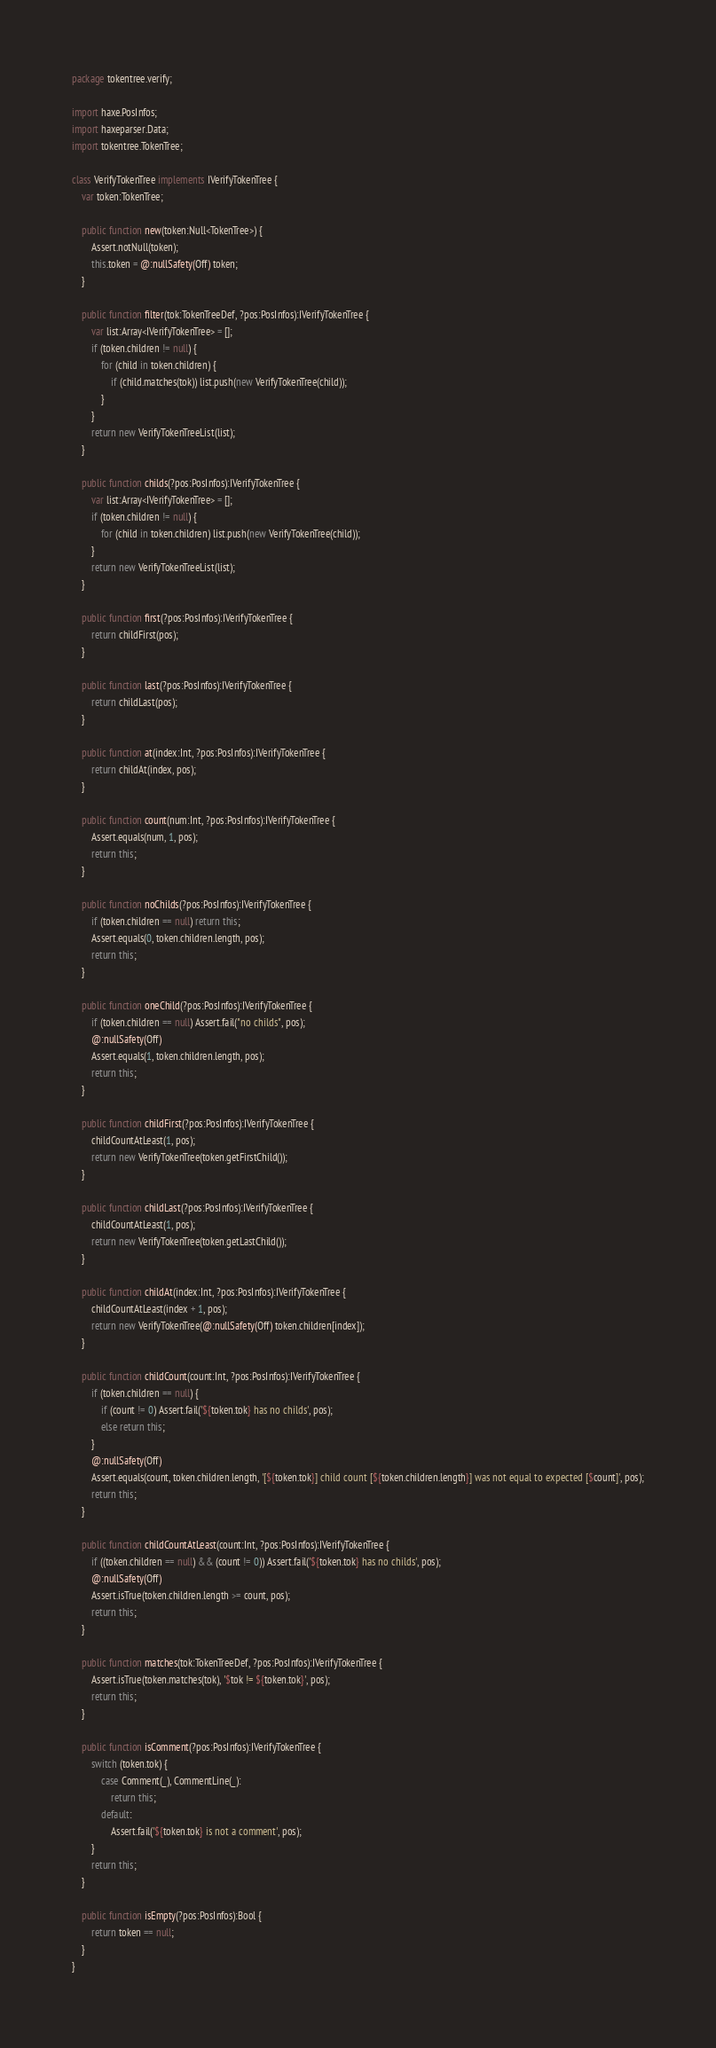<code> <loc_0><loc_0><loc_500><loc_500><_Haxe_>package tokentree.verify;

import haxe.PosInfos;
import haxeparser.Data;
import tokentree.TokenTree;

class VerifyTokenTree implements IVerifyTokenTree {
	var token:TokenTree;

	public function new(token:Null<TokenTree>) {
		Assert.notNull(token);
		this.token = @:nullSafety(Off) token;
	}

	public function filter(tok:TokenTreeDef, ?pos:PosInfos):IVerifyTokenTree {
		var list:Array<IVerifyTokenTree> = [];
		if (token.children != null) {
			for (child in token.children) {
				if (child.matches(tok)) list.push(new VerifyTokenTree(child));
			}
		}
		return new VerifyTokenTreeList(list);
	}

	public function childs(?pos:PosInfos):IVerifyTokenTree {
		var list:Array<IVerifyTokenTree> = [];
		if (token.children != null) {
			for (child in token.children) list.push(new VerifyTokenTree(child));
		}
		return new VerifyTokenTreeList(list);
	}

	public function first(?pos:PosInfos):IVerifyTokenTree {
		return childFirst(pos);
	}

	public function last(?pos:PosInfos):IVerifyTokenTree {
		return childLast(pos);
	}

	public function at(index:Int, ?pos:PosInfos):IVerifyTokenTree {
		return childAt(index, pos);
	}

	public function count(num:Int, ?pos:PosInfos):IVerifyTokenTree {
		Assert.equals(num, 1, pos);
		return this;
	}

	public function noChilds(?pos:PosInfos):IVerifyTokenTree {
		if (token.children == null) return this;
		Assert.equals(0, token.children.length, pos);
		return this;
	}

	public function oneChild(?pos:PosInfos):IVerifyTokenTree {
		if (token.children == null) Assert.fail("no childs", pos);
		@:nullSafety(Off)
		Assert.equals(1, token.children.length, pos);
		return this;
	}

	public function childFirst(?pos:PosInfos):IVerifyTokenTree {
		childCountAtLeast(1, pos);
		return new VerifyTokenTree(token.getFirstChild());
	}

	public function childLast(?pos:PosInfos):IVerifyTokenTree {
		childCountAtLeast(1, pos);
		return new VerifyTokenTree(token.getLastChild());
	}

	public function childAt(index:Int, ?pos:PosInfos):IVerifyTokenTree {
		childCountAtLeast(index + 1, pos);
		return new VerifyTokenTree(@:nullSafety(Off) token.children[index]);
	}

	public function childCount(count:Int, ?pos:PosInfos):IVerifyTokenTree {
		if (token.children == null) {
			if (count != 0) Assert.fail('${token.tok} has no childs', pos);
			else return this;
		}
		@:nullSafety(Off)
		Assert.equals(count, token.children.length, '[${token.tok}] child count [${token.children.length}] was not equal to expected [$count]', pos);
		return this;
	}

	public function childCountAtLeast(count:Int, ?pos:PosInfos):IVerifyTokenTree {
		if ((token.children == null) && (count != 0)) Assert.fail('${token.tok} has no childs', pos);
		@:nullSafety(Off)
		Assert.isTrue(token.children.length >= count, pos);
		return this;
	}

	public function matches(tok:TokenTreeDef, ?pos:PosInfos):IVerifyTokenTree {
		Assert.isTrue(token.matches(tok), '$tok != ${token.tok}', pos);
		return this;
	}

	public function isComment(?pos:PosInfos):IVerifyTokenTree {
		switch (token.tok) {
			case Comment(_), CommentLine(_):
				return this;
			default:
				Assert.fail('${token.tok} is not a comment', pos);
		}
		return this;
	}

	public function isEmpty(?pos:PosInfos):Bool {
		return token == null;
	}
}</code> 